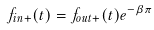Convert formula to latex. <formula><loc_0><loc_0><loc_500><loc_500>f _ { i n + } ( t ) = f _ { o u t + } ( t ) e ^ { - \beta \pi }</formula> 